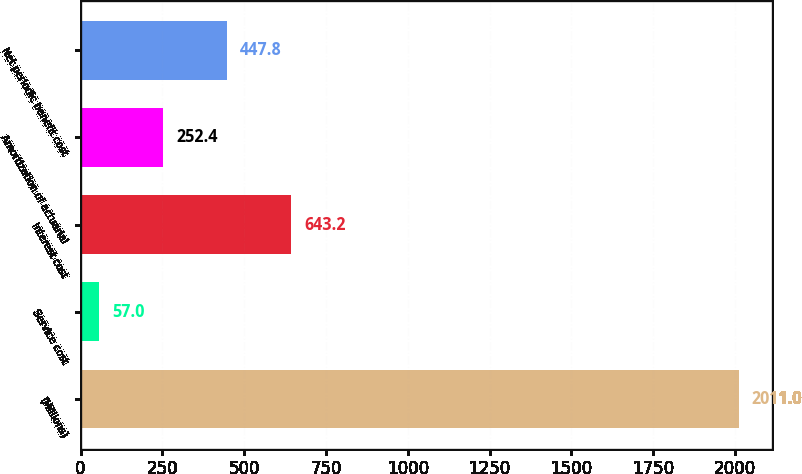Convert chart. <chart><loc_0><loc_0><loc_500><loc_500><bar_chart><fcel>(Millions)<fcel>Service cost<fcel>Interest cost<fcel>Amortization of actuarial<fcel>Net periodic benefit cost<nl><fcel>2011<fcel>57<fcel>643.2<fcel>252.4<fcel>447.8<nl></chart> 